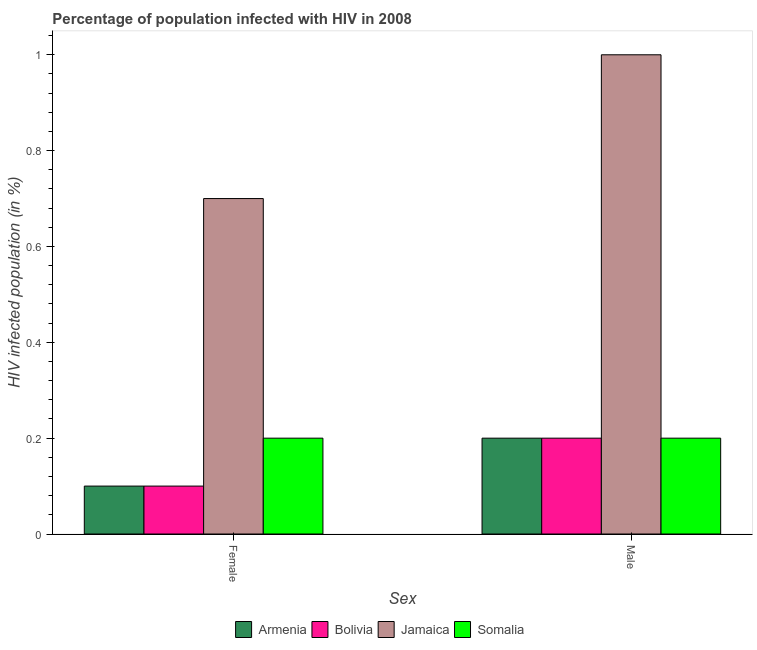How many different coloured bars are there?
Offer a terse response. 4. Are the number of bars per tick equal to the number of legend labels?
Ensure brevity in your answer.  Yes. How many bars are there on the 2nd tick from the left?
Your answer should be very brief. 4. What is the percentage of females who are infected with hiv in Armenia?
Provide a short and direct response. 0.1. Across all countries, what is the maximum percentage of males who are infected with hiv?
Your answer should be very brief. 1. Across all countries, what is the minimum percentage of males who are infected with hiv?
Make the answer very short. 0.2. In which country was the percentage of females who are infected with hiv maximum?
Provide a short and direct response. Jamaica. In which country was the percentage of females who are infected with hiv minimum?
Your answer should be compact. Armenia. What is the total percentage of females who are infected with hiv in the graph?
Your response must be concise. 1.1. What is the difference between the percentage of females who are infected with hiv in Armenia and the percentage of males who are infected with hiv in Jamaica?
Ensure brevity in your answer.  -0.9. What is the average percentage of males who are infected with hiv per country?
Offer a very short reply. 0.4. What is the difference between the percentage of females who are infected with hiv and percentage of males who are infected with hiv in Somalia?
Give a very brief answer. 0. In how many countries, is the percentage of females who are infected with hiv greater than 0.7200000000000001 %?
Your answer should be compact. 0. What is the ratio of the percentage of males who are infected with hiv in Armenia to that in Jamaica?
Your answer should be compact. 0.2. In how many countries, is the percentage of females who are infected with hiv greater than the average percentage of females who are infected with hiv taken over all countries?
Your response must be concise. 1. What does the 3rd bar from the left in Male represents?
Give a very brief answer. Jamaica. What does the 3rd bar from the right in Male represents?
Provide a succinct answer. Bolivia. Does the graph contain grids?
Offer a very short reply. No. How many legend labels are there?
Your response must be concise. 4. How are the legend labels stacked?
Ensure brevity in your answer.  Horizontal. What is the title of the graph?
Offer a terse response. Percentage of population infected with HIV in 2008. What is the label or title of the X-axis?
Ensure brevity in your answer.  Sex. What is the label or title of the Y-axis?
Your answer should be compact. HIV infected population (in %). What is the HIV infected population (in %) of Armenia in Female?
Provide a succinct answer. 0.1. What is the HIV infected population (in %) of Bolivia in Female?
Offer a terse response. 0.1. What is the HIV infected population (in %) in Jamaica in Female?
Offer a very short reply. 0.7. What is the HIV infected population (in %) in Armenia in Male?
Keep it short and to the point. 0.2. What is the HIV infected population (in %) in Bolivia in Male?
Offer a terse response. 0.2. Across all Sex, what is the maximum HIV infected population (in %) of Armenia?
Your response must be concise. 0.2. Across all Sex, what is the maximum HIV infected population (in %) of Bolivia?
Ensure brevity in your answer.  0.2. Across all Sex, what is the maximum HIV infected population (in %) of Somalia?
Keep it short and to the point. 0.2. Across all Sex, what is the minimum HIV infected population (in %) of Armenia?
Your answer should be compact. 0.1. Across all Sex, what is the minimum HIV infected population (in %) of Bolivia?
Provide a succinct answer. 0.1. What is the total HIV infected population (in %) in Bolivia in the graph?
Make the answer very short. 0.3. What is the total HIV infected population (in %) in Somalia in the graph?
Keep it short and to the point. 0.4. What is the difference between the HIV infected population (in %) of Armenia in Female and that in Male?
Offer a terse response. -0.1. What is the difference between the HIV infected population (in %) in Bolivia in Female and that in Male?
Your answer should be compact. -0.1. What is the difference between the HIV infected population (in %) in Jamaica in Female and that in Male?
Your answer should be compact. -0.3. What is the difference between the HIV infected population (in %) of Armenia in Female and the HIV infected population (in %) of Bolivia in Male?
Provide a short and direct response. -0.1. What is the difference between the HIV infected population (in %) in Armenia in Female and the HIV infected population (in %) in Somalia in Male?
Your response must be concise. -0.1. What is the difference between the HIV infected population (in %) in Bolivia in Female and the HIV infected population (in %) in Jamaica in Male?
Offer a terse response. -0.9. What is the average HIV infected population (in %) in Jamaica per Sex?
Ensure brevity in your answer.  0.85. What is the average HIV infected population (in %) in Somalia per Sex?
Keep it short and to the point. 0.2. What is the difference between the HIV infected population (in %) in Armenia and HIV infected population (in %) in Bolivia in Female?
Give a very brief answer. 0. What is the difference between the HIV infected population (in %) in Armenia and HIV infected population (in %) in Jamaica in Female?
Keep it short and to the point. -0.6. What is the difference between the HIV infected population (in %) in Armenia and HIV infected population (in %) in Somalia in Female?
Offer a terse response. -0.1. What is the difference between the HIV infected population (in %) in Bolivia and HIV infected population (in %) in Somalia in Female?
Provide a short and direct response. -0.1. What is the difference between the HIV infected population (in %) in Jamaica and HIV infected population (in %) in Somalia in Female?
Give a very brief answer. 0.5. What is the difference between the HIV infected population (in %) in Armenia and HIV infected population (in %) in Bolivia in Male?
Give a very brief answer. 0. What is the difference between the HIV infected population (in %) in Bolivia and HIV infected population (in %) in Somalia in Male?
Give a very brief answer. 0. What is the difference between the HIV infected population (in %) in Jamaica and HIV infected population (in %) in Somalia in Male?
Keep it short and to the point. 0.8. What is the ratio of the HIV infected population (in %) in Somalia in Female to that in Male?
Offer a terse response. 1. What is the difference between the highest and the second highest HIV infected population (in %) of Jamaica?
Your answer should be very brief. 0.3. What is the difference between the highest and the lowest HIV infected population (in %) in Armenia?
Offer a very short reply. 0.1. What is the difference between the highest and the lowest HIV infected population (in %) in Somalia?
Give a very brief answer. 0. 